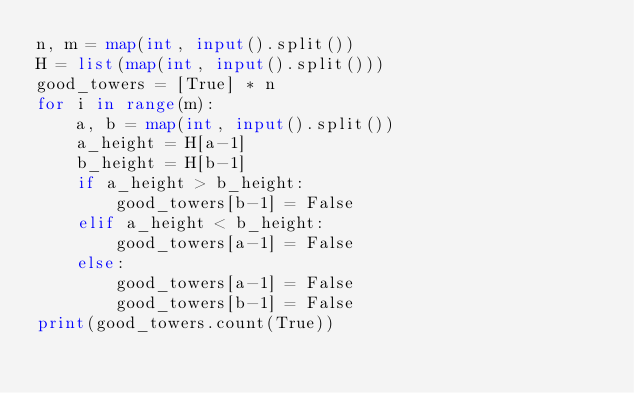<code> <loc_0><loc_0><loc_500><loc_500><_Python_>n, m = map(int, input().split())
H = list(map(int, input().split()))
good_towers = [True] * n
for i in range(m):
    a, b = map(int, input().split())
    a_height = H[a-1]
    b_height = H[b-1]
    if a_height > b_height:
        good_towers[b-1] = False
    elif a_height < b_height:
        good_towers[a-1] = False
    else:
        good_towers[a-1] = False
        good_towers[b-1] = False
print(good_towers.count(True))
</code> 